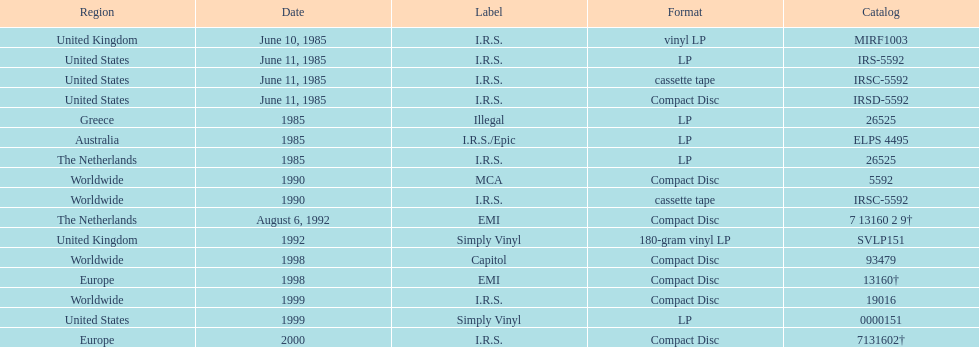Which country or region had the most releases? Worldwide. 